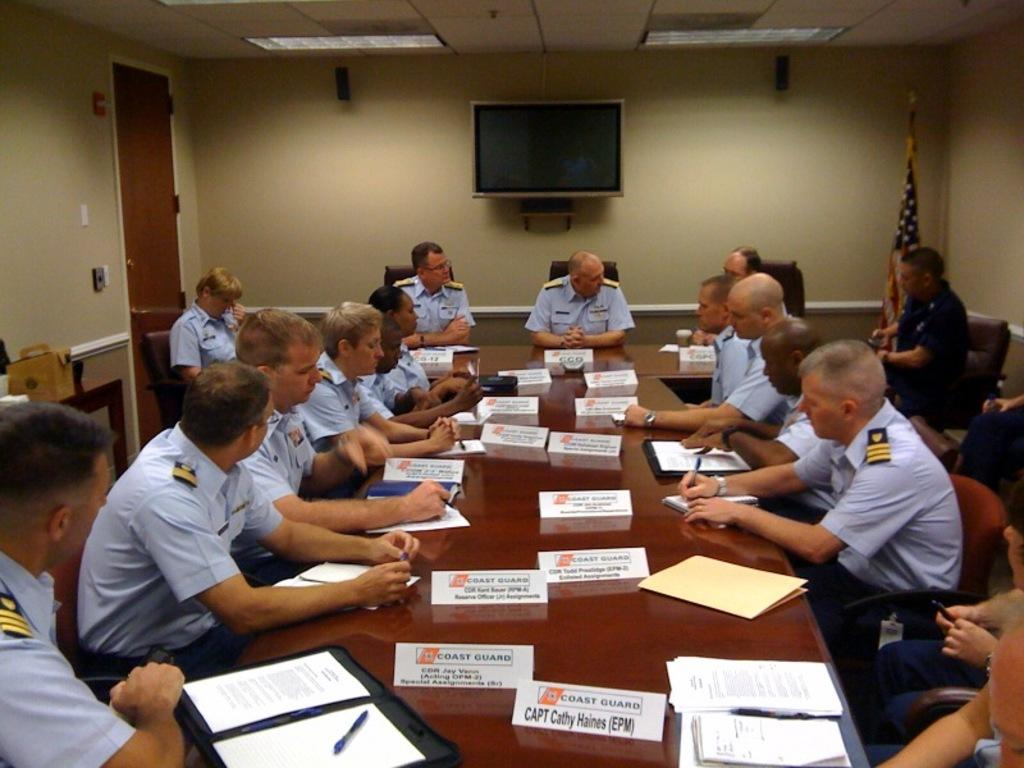<image>
Render a clear and concise summary of the photo. Captain Cathy Haines is one of the people at this table. 